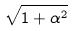<formula> <loc_0><loc_0><loc_500><loc_500>\sqrt { 1 + \alpha ^ { 2 } }</formula> 